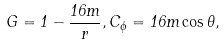<formula> <loc_0><loc_0><loc_500><loc_500>G = 1 - \frac { 1 6 m } { r } , C _ { \phi } = 1 6 m \cos \theta ,</formula> 